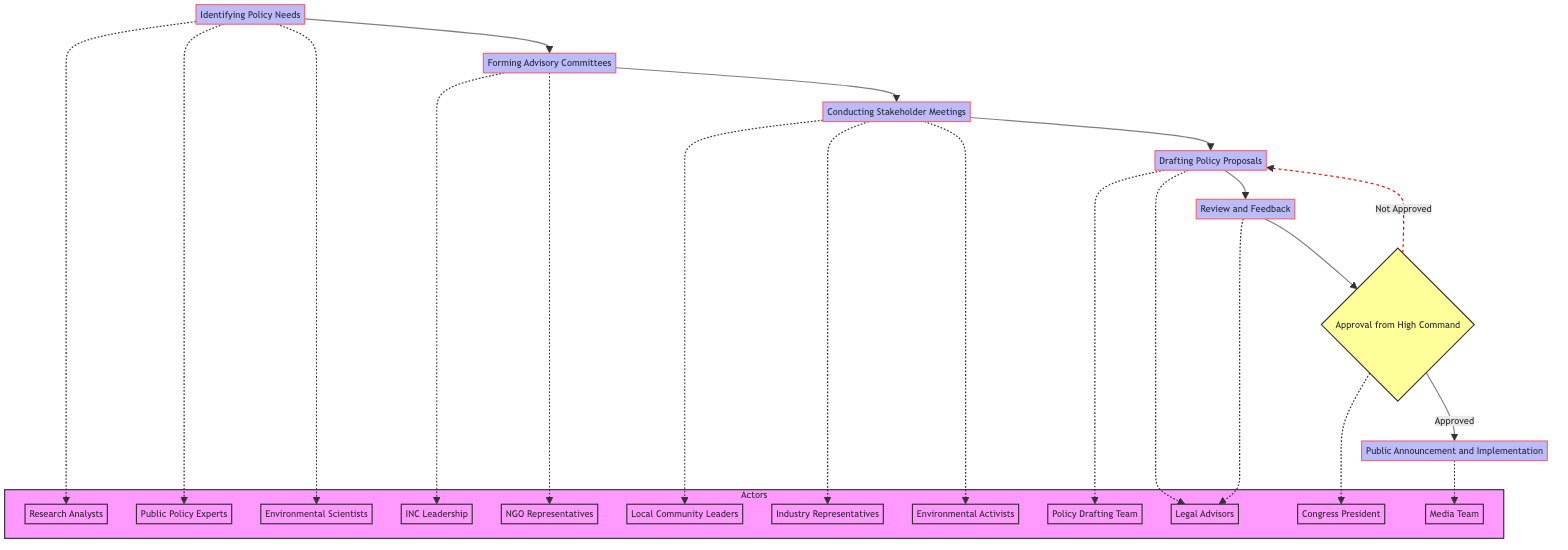What is the first step in the decision-making process within the INC? The first step in the decision-making process is "Identifying Policy Needs." It is indicated as the starting point in the flowchart.
Answer: Identifying Policy Needs How many steps are there in total in the decision-making process? By counting the nodes in the flowchart, there are seven distinct steps shown in the diagram.
Answer: Seven Which step directly follows "Drafting Policy Proposals"? According to the flowchart, "Review and Feedback" is the step that comes immediately after "Drafting Policy Proposals."
Answer: Review and Feedback Who is involved in the "Public Announcement and Implementation"? The actors involved in this step include the "Media and Communication Team," "Sectoral Departments," "Local Governments," and "Monitoring Agencies," as outlined in the diagram.
Answer: Media and Communication Team, Sectoral Departments, Local Governments, Monitoring Agencies What happens if the "Approval from High Command" is not granted? If the approval is not granted, the process returns to "Drafting Policy Proposals," as depicted by the flowchart's decision point.
Answer: Drafting Policy Proposals How many actors contribute to the "Conducting Stakeholder Meetings"? The diagram lists four actors who contribute to this step: "Local Community Leaders," "Industry Representatives," "Environmental Activists," and "INC Members."
Answer: Four What is the role of the "Central Working Committee" in the process? The "Central Working Committee" is responsible for providing feedback on the drafted policies during the "Review and Feedback" step, according to the flowchart.
Answer: Providing feedback Which actors are involved in the "Forming Advisory Committees"? The actors involved in this step are "INC Leadership," "Subject Matter Experts," and "NGO Representatives," as specified in the flowchart.
Answer: INC Leadership, Subject Matter Experts, NGO Representatives If a policy proposal is approved, what is the next step? If a policy proposal is approved, the next step is "Public Announcement and Implementation," as shown in the flowchart.
Answer: Public Announcement and Implementation 